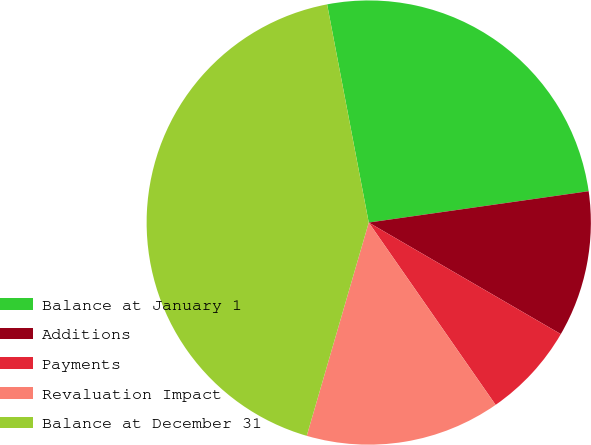Convert chart to OTSL. <chart><loc_0><loc_0><loc_500><loc_500><pie_chart><fcel>Balance at January 1<fcel>Additions<fcel>Payments<fcel>Revaluation Impact<fcel>Balance at December 31<nl><fcel>25.75%<fcel>10.63%<fcel>6.95%<fcel>14.18%<fcel>42.5%<nl></chart> 